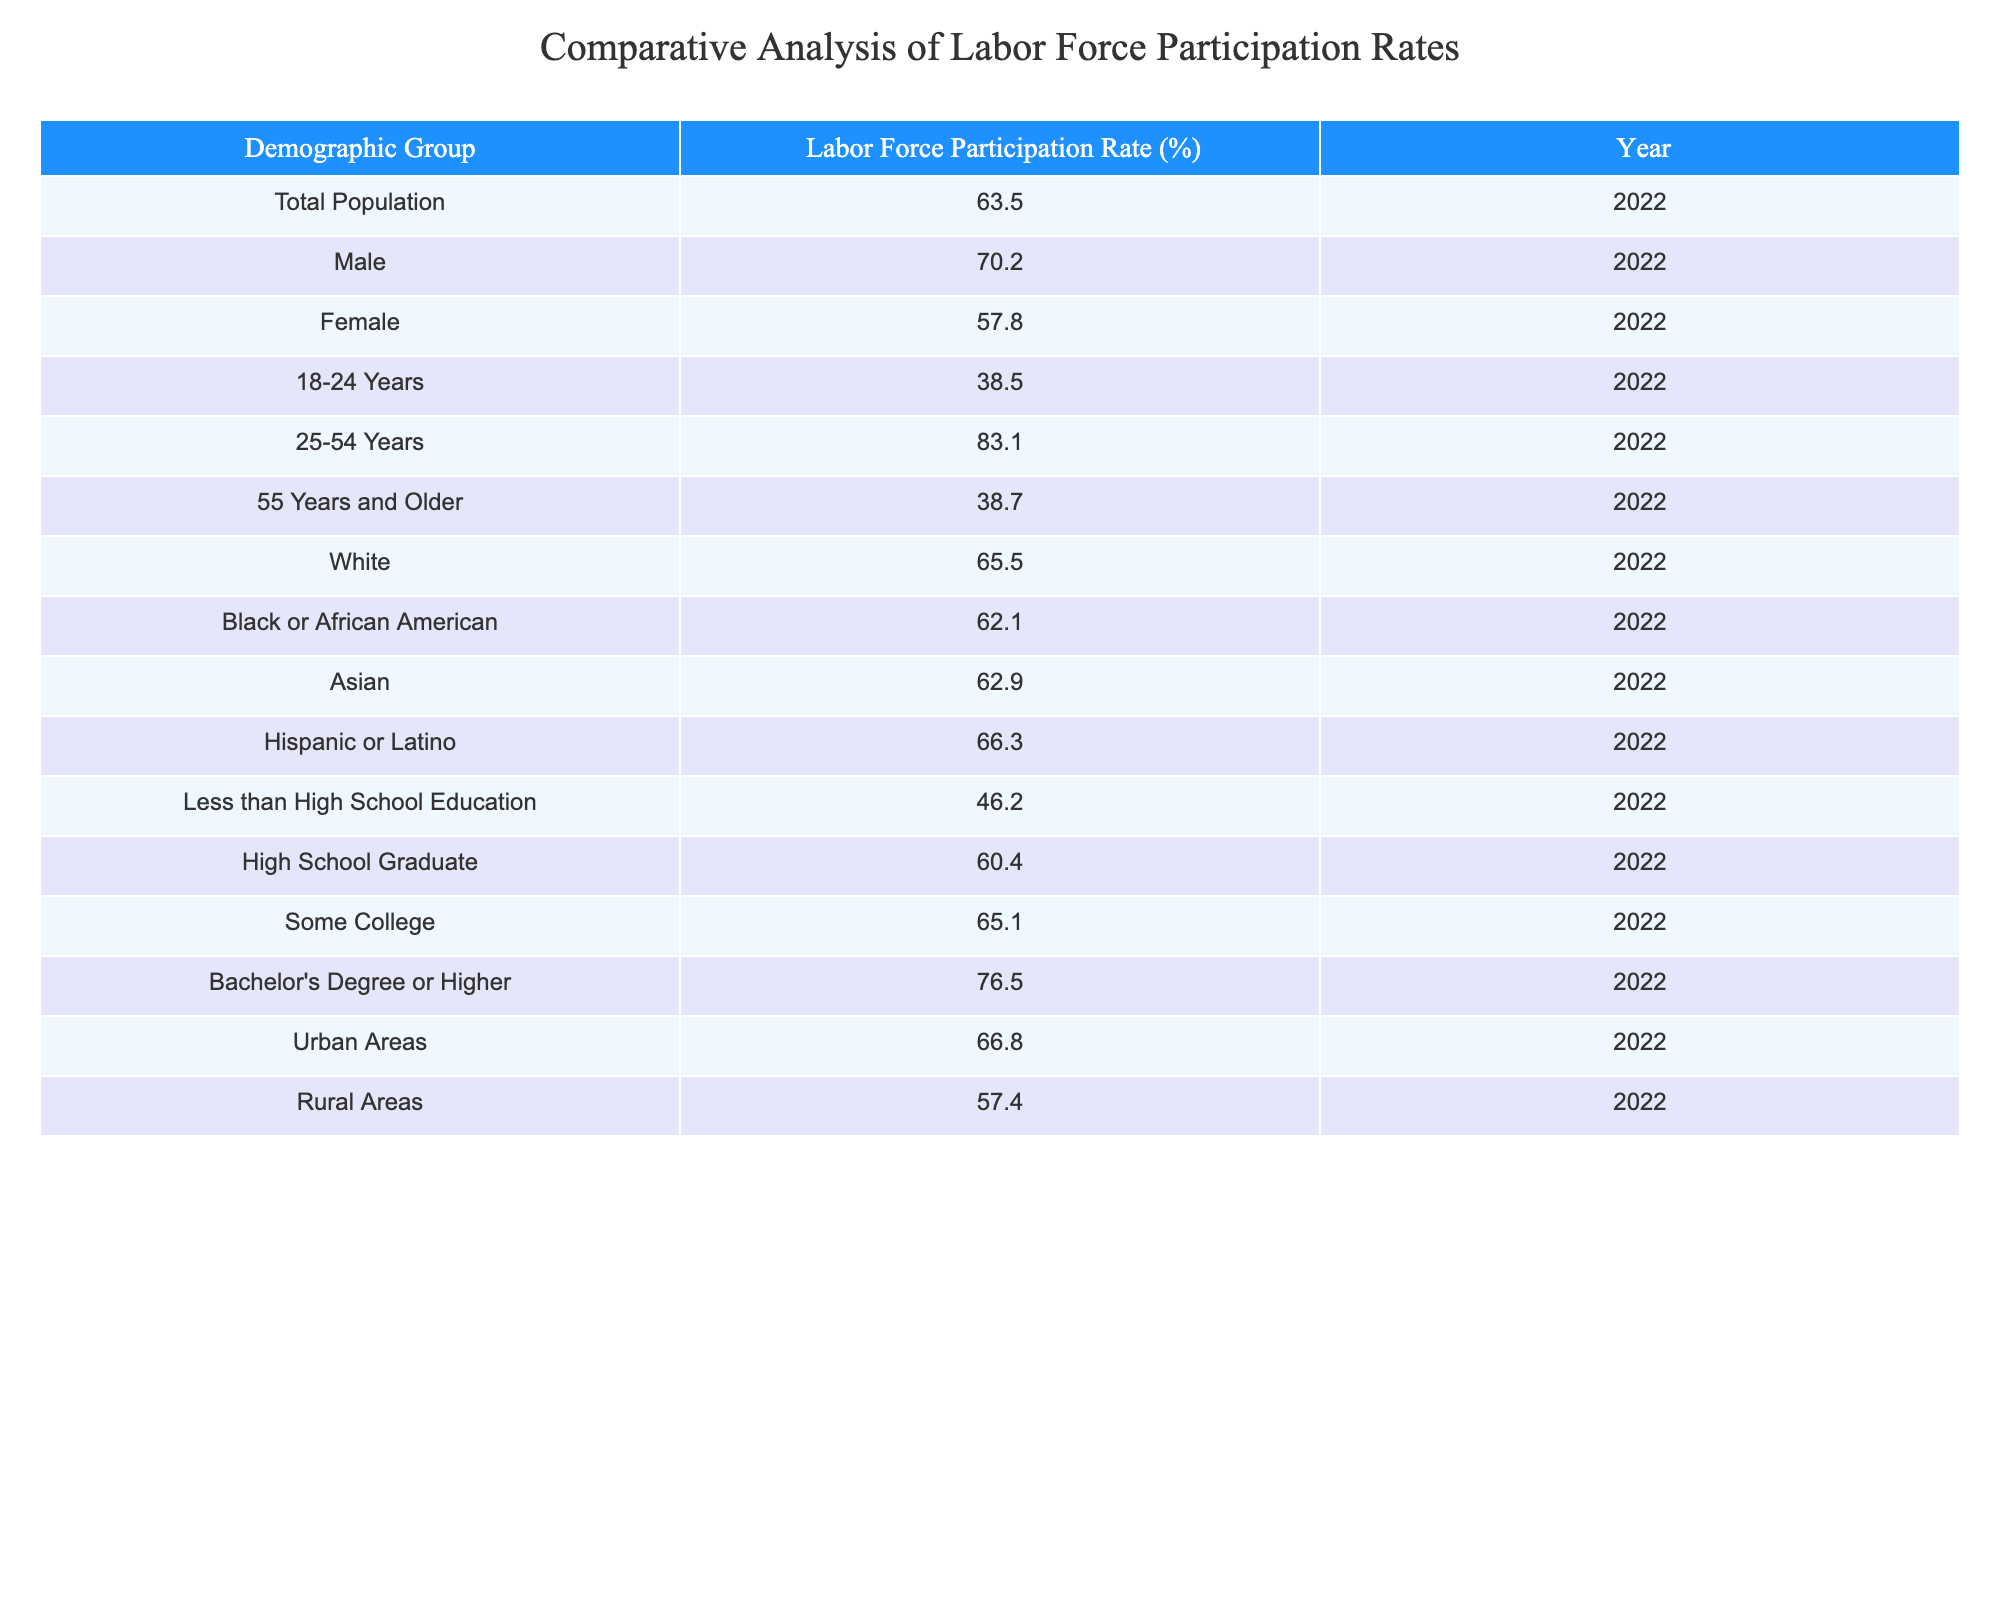What is the Labor Force Participation Rate for females in 2022? The table lists the Labor Force Participation Rates by demographic group for the year 2022. Looking under the Female category, the table shows a rate of 57.8%.
Answer: 57.8% Which age group has the highest Labor Force Participation Rate? The table includes participation rates categorized by age groups. The 25-54 Years group has a participation rate of 83.1%, which is higher than all other age groups listed.
Answer: 25-54 Years What is the difference in Labor Force Participation Rates between males and females? To find the difference, subtract the female rate (57.8%) from the male rate (70.2%). This gives us 70.2% - 57.8% = 12.4%.
Answer: 12.4% Is the Labor Force Participation Rate for rural areas higher than that for females? The rate for females is 57.8% and for rural areas, it is 57.4%. Since 57.8% is greater than 57.4%, the statement is false.
Answer: No What demographic group has the lowest Labor Force Participation Rate? Looking through the rates provided, the Less than High School Education group has a participation rate of 46.2%, which is lower than all other groups listed.
Answer: Less than High School Education What is the average Labor Force Participation Rate for the age groups (18-24 Years, 25-54 Years, 55 Years and Older)? First, we sum the participation rates for the three age groups: 38.5% (18-24) + 83.1% (25-54) + 38.7% (55 and older) = 160.3%. Then, divide by the number of groups (3): 160.3% ÷ 3 = 53.433%.
Answer: 53.4% Is the Labor Force Participation Rate for the Hispanic or Latino demographic higher than that of the Asian demographic? The Hispanic or Latino rate is 66.3%, while the Asian rate is 62.9%. Since 66.3% is greater than 62.9%, the statement is true.
Answer: Yes What is the Labor Force Participation Rate for those with a Bachelor's Degree or Higher compared to those with Less than High School Education? The Bachelor’s Degree or Higher group has a rate of 76.5%, while the Less than High School Education group has a rate of 46.2%. To compare, 76.5% is significantly higher than 46.2%.
Answer: 76.5% vs. 46.2% 